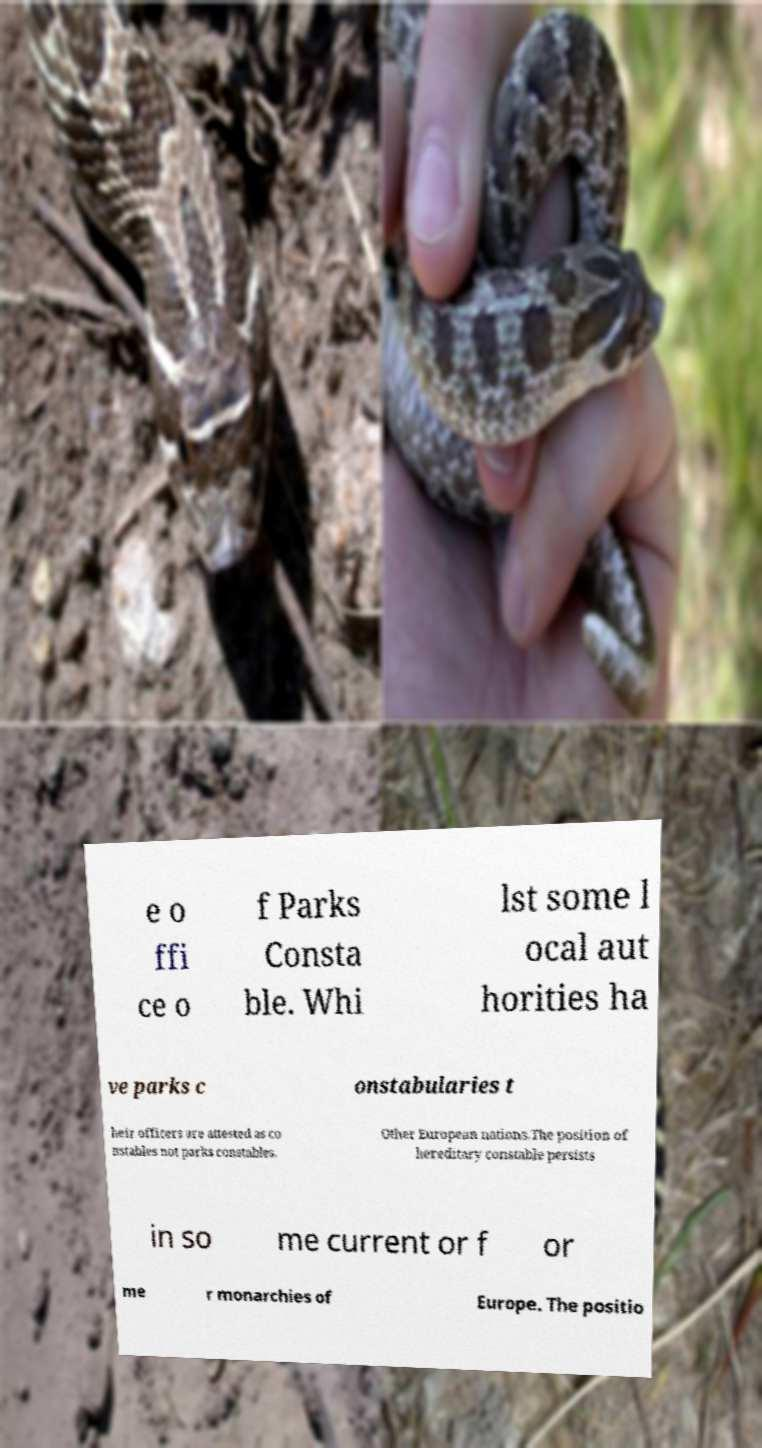Can you accurately transcribe the text from the provided image for me? e o ffi ce o f Parks Consta ble. Whi lst some l ocal aut horities ha ve parks c onstabularies t heir officers are attested as co nstables not parks constables. Other European nations.The position of hereditary constable persists in so me current or f or me r monarchies of Europe. The positio 